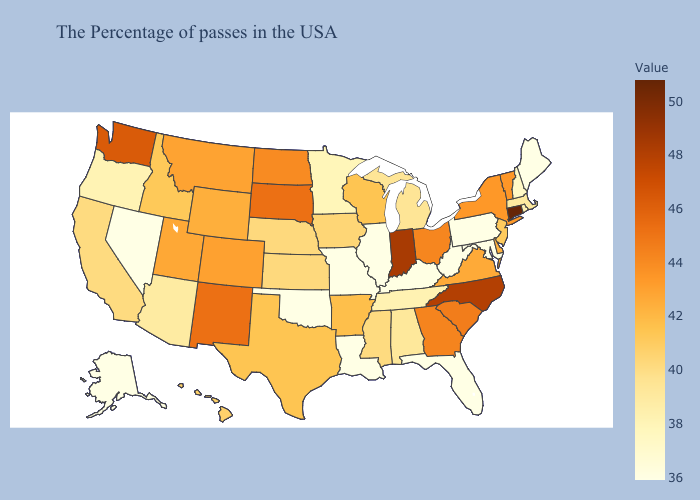Does Oklahoma have the highest value in the USA?
Write a very short answer. No. Which states hav the highest value in the Northeast?
Quick response, please. Connecticut. Does Iowa have the highest value in the MidWest?
Write a very short answer. No. Does the map have missing data?
Quick response, please. No. Which states have the lowest value in the USA?
Short answer required. Maine, Maryland, Pennsylvania, West Virginia, Florida, Illinois, Louisiana, Missouri, Oklahoma, Nevada, Alaska. Which states have the highest value in the USA?
Short answer required. Connecticut. Which states have the lowest value in the USA?
Concise answer only. Maine, Maryland, Pennsylvania, West Virginia, Florida, Illinois, Louisiana, Missouri, Oklahoma, Nevada, Alaska. Which states have the lowest value in the USA?
Keep it brief. Maine, Maryland, Pennsylvania, West Virginia, Florida, Illinois, Louisiana, Missouri, Oklahoma, Nevada, Alaska. Among the states that border Kansas , does Nebraska have the lowest value?
Answer briefly. No. Is the legend a continuous bar?
Quick response, please. Yes. 